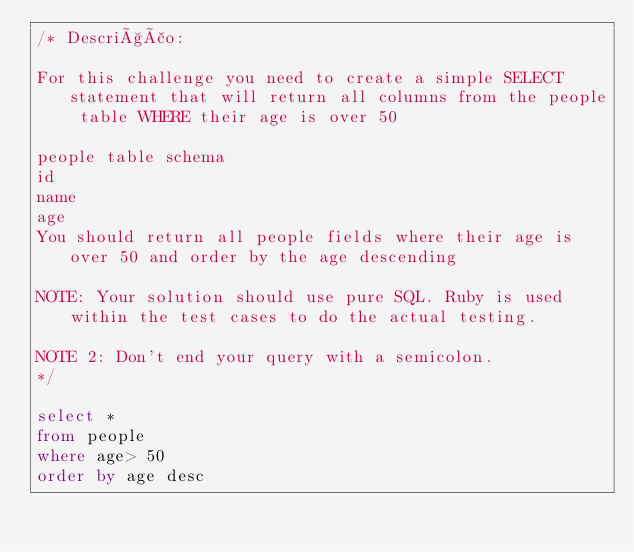Convert code to text. <code><loc_0><loc_0><loc_500><loc_500><_SQL_>/* Descrição:

For this challenge you need to create a simple SELECT statement that will return all columns from the people table WHERE their age is over 50

people table schema
id
name
age
You should return all people fields where their age is over 50 and order by the age descending

NOTE: Your solution should use pure SQL. Ruby is used within the test cases to do the actual testing.

NOTE 2: Don't end your query with a semicolon.
*/

select *
from people
where age> 50
order by age desc</code> 